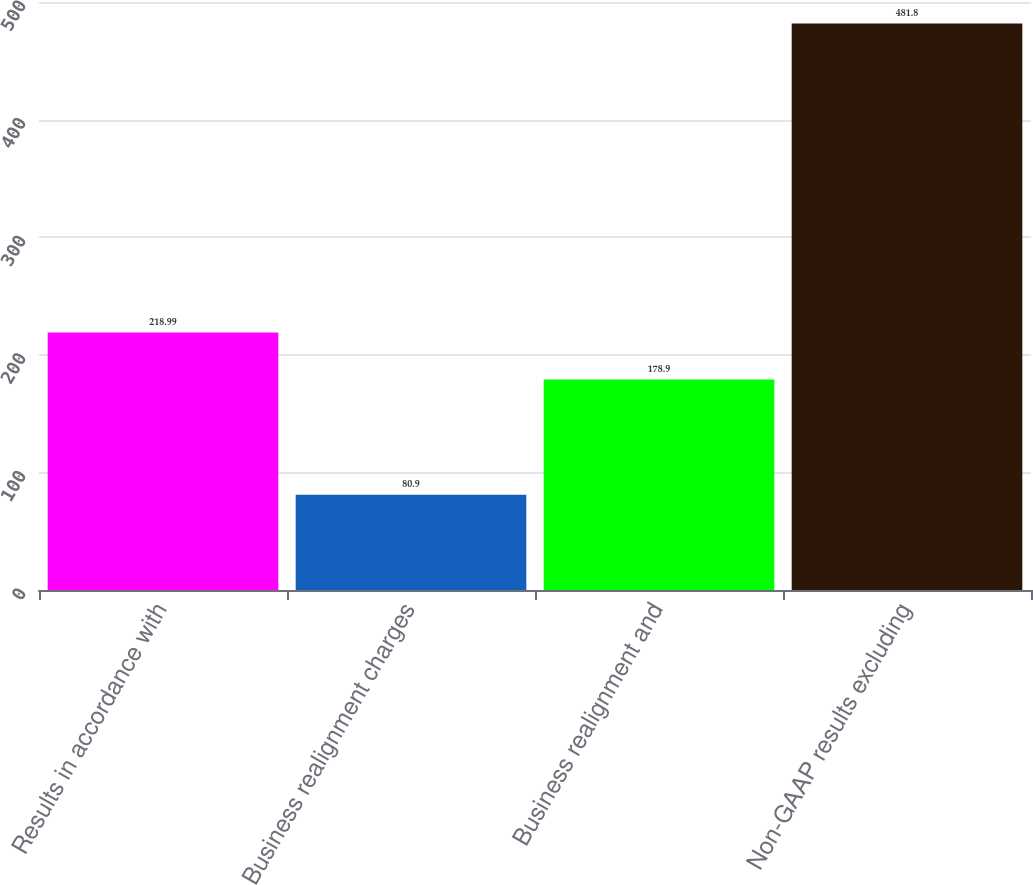Convert chart. <chart><loc_0><loc_0><loc_500><loc_500><bar_chart><fcel>Results in accordance with<fcel>Business realignment charges<fcel>Business realignment and<fcel>Non-GAAP results excluding<nl><fcel>218.99<fcel>80.9<fcel>178.9<fcel>481.8<nl></chart> 